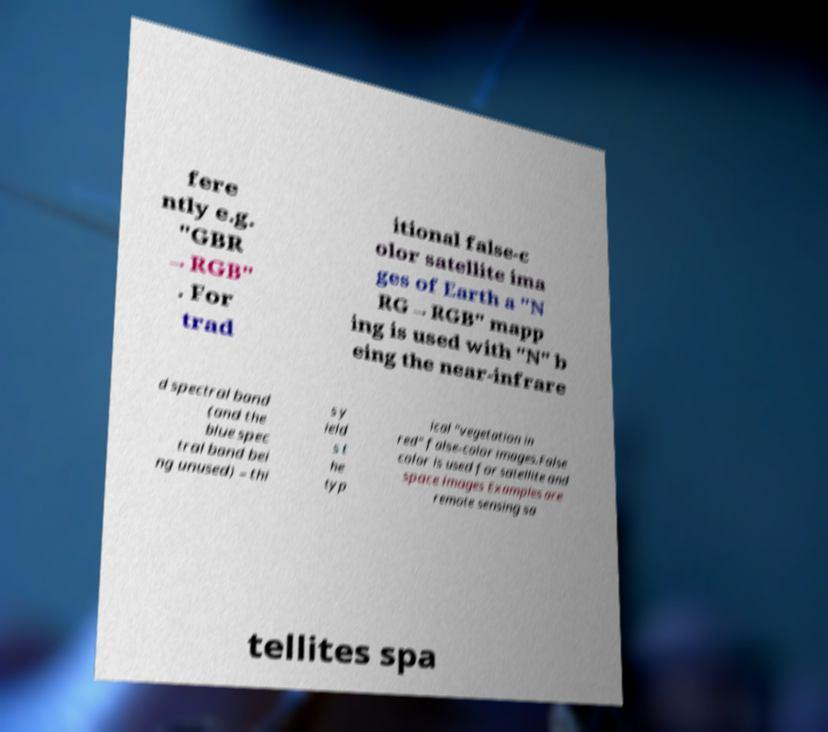There's text embedded in this image that I need extracted. Can you transcribe it verbatim? fere ntly e.g. "GBR →RGB" . For trad itional false-c olor satellite ima ges of Earth a "N RG→RGB" mapp ing is used with "N" b eing the near-infrare d spectral band (and the blue spec tral band bei ng unused) – thi s y ield s t he typ ical "vegetation in red" false-color images.False color is used for satellite and space images Examples are remote sensing sa tellites spa 